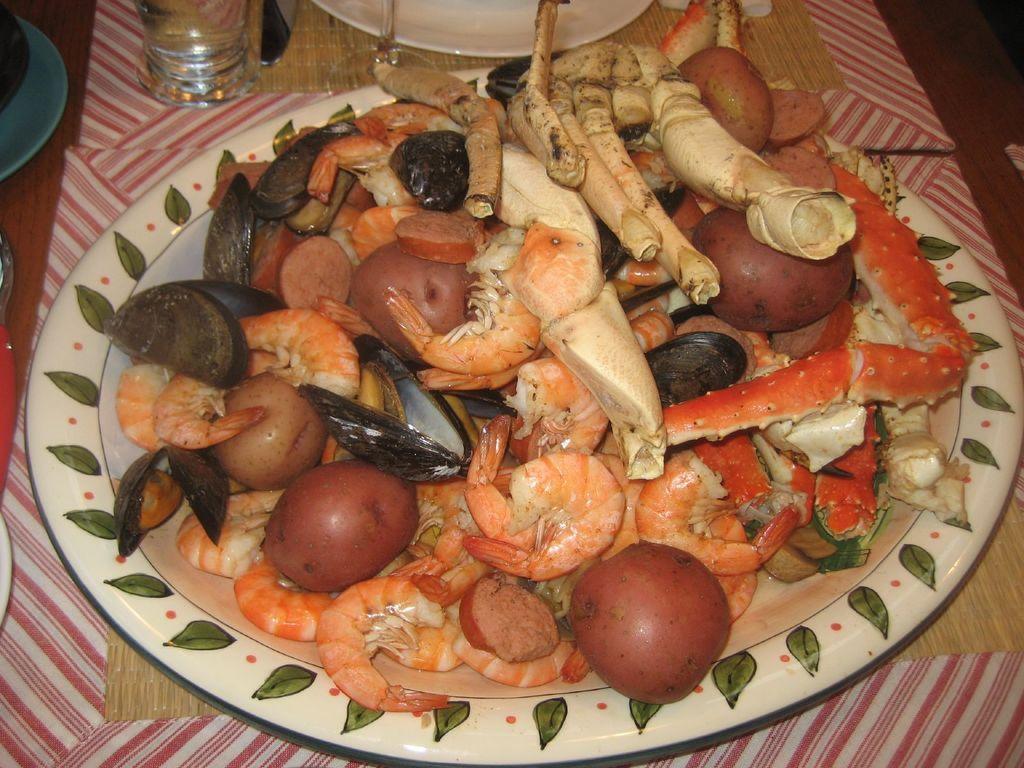How would you summarize this image in a sentence or two? In this image there are few plates, glasses are on the table. Plates are kept on the mat. On the plate there are few potatoes and some food are on it. Top of the image there are two plates and two glasses are on the table. 